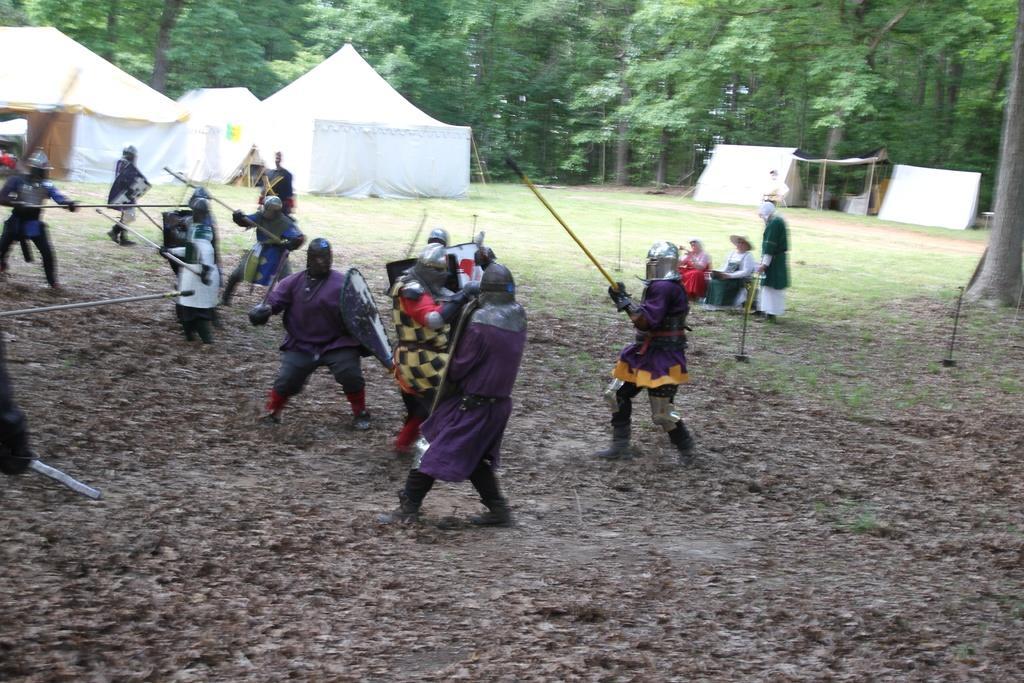Can you describe this image briefly? In this image, I can see groups of people in warrior costumes and holding the sticks. I can see two persons sitting. In the background there are tents and trees. 